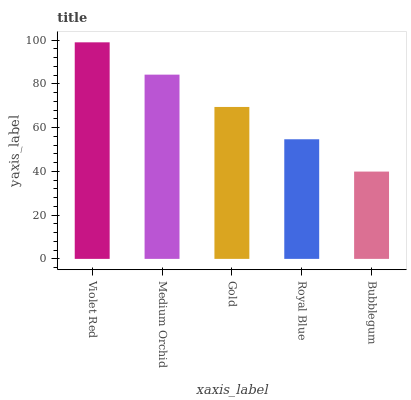Is Bubblegum the minimum?
Answer yes or no. Yes. Is Violet Red the maximum?
Answer yes or no. Yes. Is Medium Orchid the minimum?
Answer yes or no. No. Is Medium Orchid the maximum?
Answer yes or no. No. Is Violet Red greater than Medium Orchid?
Answer yes or no. Yes. Is Medium Orchid less than Violet Red?
Answer yes or no. Yes. Is Medium Orchid greater than Violet Red?
Answer yes or no. No. Is Violet Red less than Medium Orchid?
Answer yes or no. No. Is Gold the high median?
Answer yes or no. Yes. Is Gold the low median?
Answer yes or no. Yes. Is Medium Orchid the high median?
Answer yes or no. No. Is Royal Blue the low median?
Answer yes or no. No. 